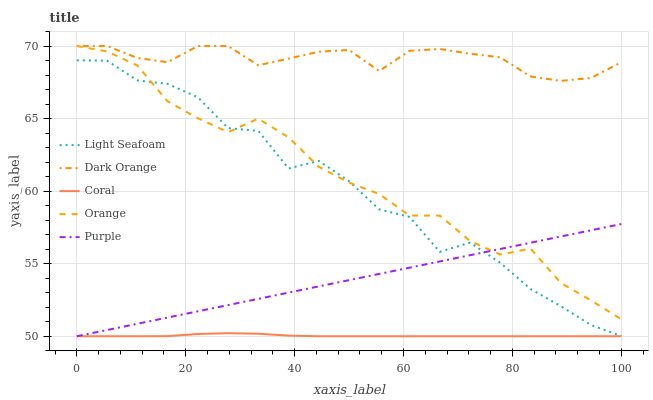Does Coral have the minimum area under the curve?
Answer yes or no. Yes. Does Dark Orange have the maximum area under the curve?
Answer yes or no. Yes. Does Dark Orange have the minimum area under the curve?
Answer yes or no. No. Does Coral have the maximum area under the curve?
Answer yes or no. No. Is Purple the smoothest?
Answer yes or no. Yes. Is Light Seafoam the roughest?
Answer yes or no. Yes. Is Dark Orange the smoothest?
Answer yes or no. No. Is Dark Orange the roughest?
Answer yes or no. No. Does Coral have the lowest value?
Answer yes or no. Yes. Does Dark Orange have the lowest value?
Answer yes or no. No. Does Dark Orange have the highest value?
Answer yes or no. Yes. Does Coral have the highest value?
Answer yes or no. No. Is Purple less than Dark Orange?
Answer yes or no. Yes. Is Dark Orange greater than Coral?
Answer yes or no. Yes. Does Purple intersect Coral?
Answer yes or no. Yes. Is Purple less than Coral?
Answer yes or no. No. Is Purple greater than Coral?
Answer yes or no. No. Does Purple intersect Dark Orange?
Answer yes or no. No. 